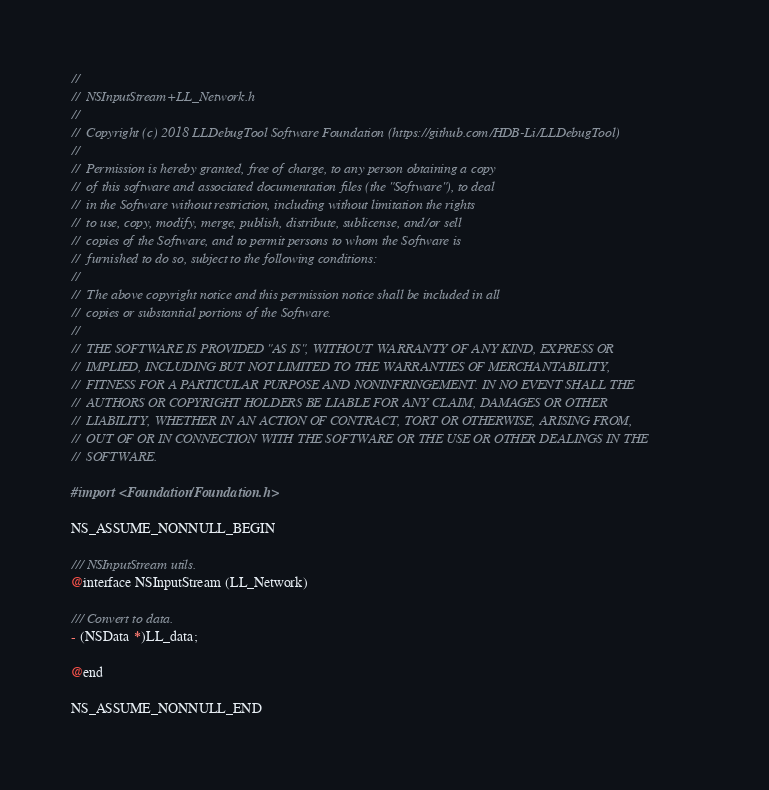Convert code to text. <code><loc_0><loc_0><loc_500><loc_500><_C_>//
//  NSInputStream+LL_Network.h
//
//  Copyright (c) 2018 LLDebugTool Software Foundation (https://github.com/HDB-Li/LLDebugTool)
//
//  Permission is hereby granted, free of charge, to any person obtaining a copy
//  of this software and associated documentation files (the "Software"), to deal
//  in the Software without restriction, including without limitation the rights
//  to use, copy, modify, merge, publish, distribute, sublicense, and/or sell
//  copies of the Software, and to permit persons to whom the Software is
//  furnished to do so, subject to the following conditions:
//
//  The above copyright notice and this permission notice shall be included in all
//  copies or substantial portions of the Software.
//
//  THE SOFTWARE IS PROVIDED "AS IS", WITHOUT WARRANTY OF ANY KIND, EXPRESS OR
//  IMPLIED, INCLUDING BUT NOT LIMITED TO THE WARRANTIES OF MERCHANTABILITY,
//  FITNESS FOR A PARTICULAR PURPOSE AND NONINFRINGEMENT. IN NO EVENT SHALL THE
//  AUTHORS OR COPYRIGHT HOLDERS BE LIABLE FOR ANY CLAIM, DAMAGES OR OTHER
//  LIABILITY, WHETHER IN AN ACTION OF CONTRACT, TORT OR OTHERWISE, ARISING FROM,
//  OUT OF OR IN CONNECTION WITH THE SOFTWARE OR THE USE OR OTHER DEALINGS IN THE
//  SOFTWARE.

#import <Foundation/Foundation.h>

NS_ASSUME_NONNULL_BEGIN

/// NSInputStream utils.
@interface NSInputStream (LL_Network)

/// Convert to data.
- (NSData *)LL_data;

@end

NS_ASSUME_NONNULL_END
</code> 